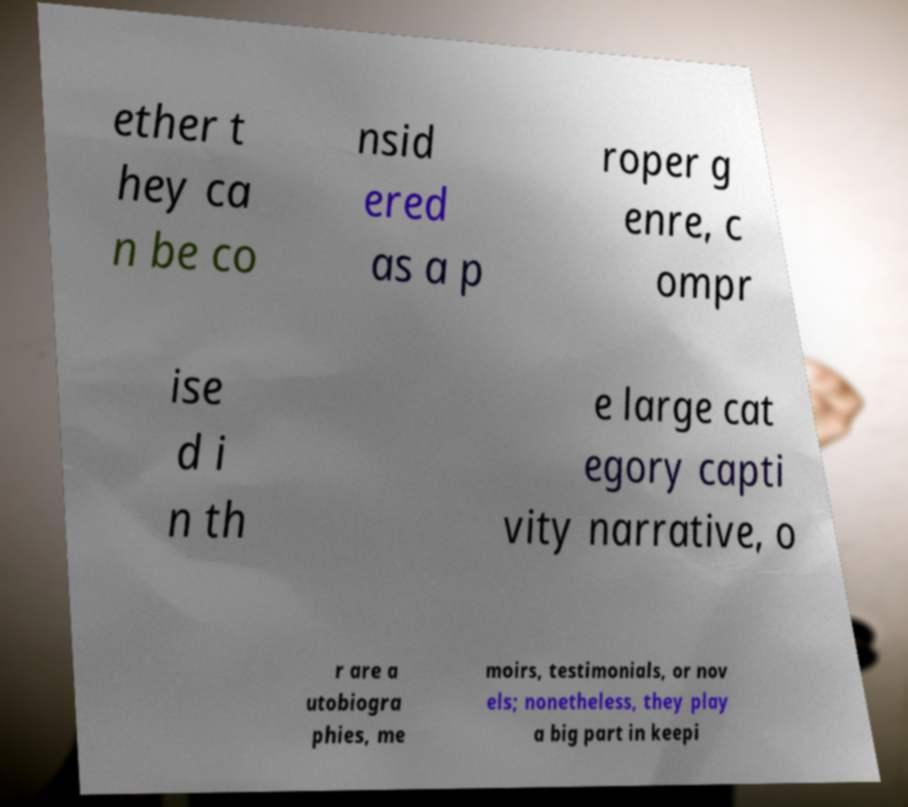I need the written content from this picture converted into text. Can you do that? ether t hey ca n be co nsid ered as a p roper g enre, c ompr ise d i n th e large cat egory capti vity narrative, o r are a utobiogra phies, me moirs, testimonials, or nov els; nonetheless, they play a big part in keepi 